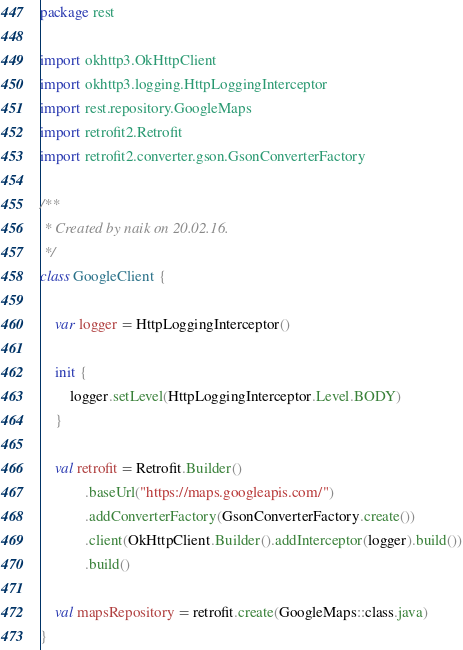Convert code to text. <code><loc_0><loc_0><loc_500><loc_500><_Kotlin_>package rest

import okhttp3.OkHttpClient
import okhttp3.logging.HttpLoggingInterceptor
import rest.repository.GoogleMaps
import retrofit2.Retrofit
import retrofit2.converter.gson.GsonConverterFactory

/**
 * Created by naik on 20.02.16.
 */
class GoogleClient {

    var logger = HttpLoggingInterceptor()

    init {
        logger.setLevel(HttpLoggingInterceptor.Level.BODY)
    }

    val retrofit = Retrofit.Builder()
            .baseUrl("https://maps.googleapis.com/")
            .addConverterFactory(GsonConverterFactory.create())
            .client(OkHttpClient.Builder().addInterceptor(logger).build())
            .build()

    val mapsRepository = retrofit.create(GoogleMaps::class.java)
}</code> 